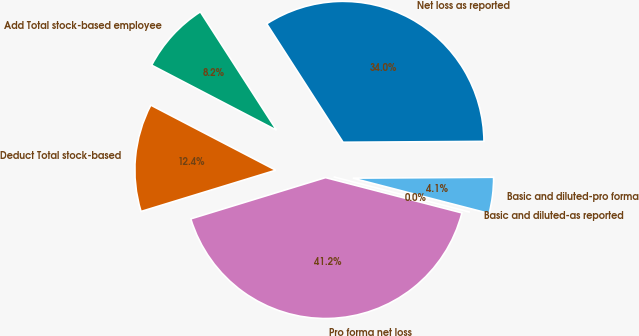Convert chart to OTSL. <chart><loc_0><loc_0><loc_500><loc_500><pie_chart><fcel>Net loss as reported<fcel>Add Total stock-based employee<fcel>Deduct Total stock-based<fcel>Pro forma net loss<fcel>Basic and diluted-as reported<fcel>Basic and diluted-pro forma<nl><fcel>34.01%<fcel>8.25%<fcel>12.37%<fcel>41.24%<fcel>0.0%<fcel>4.13%<nl></chart> 